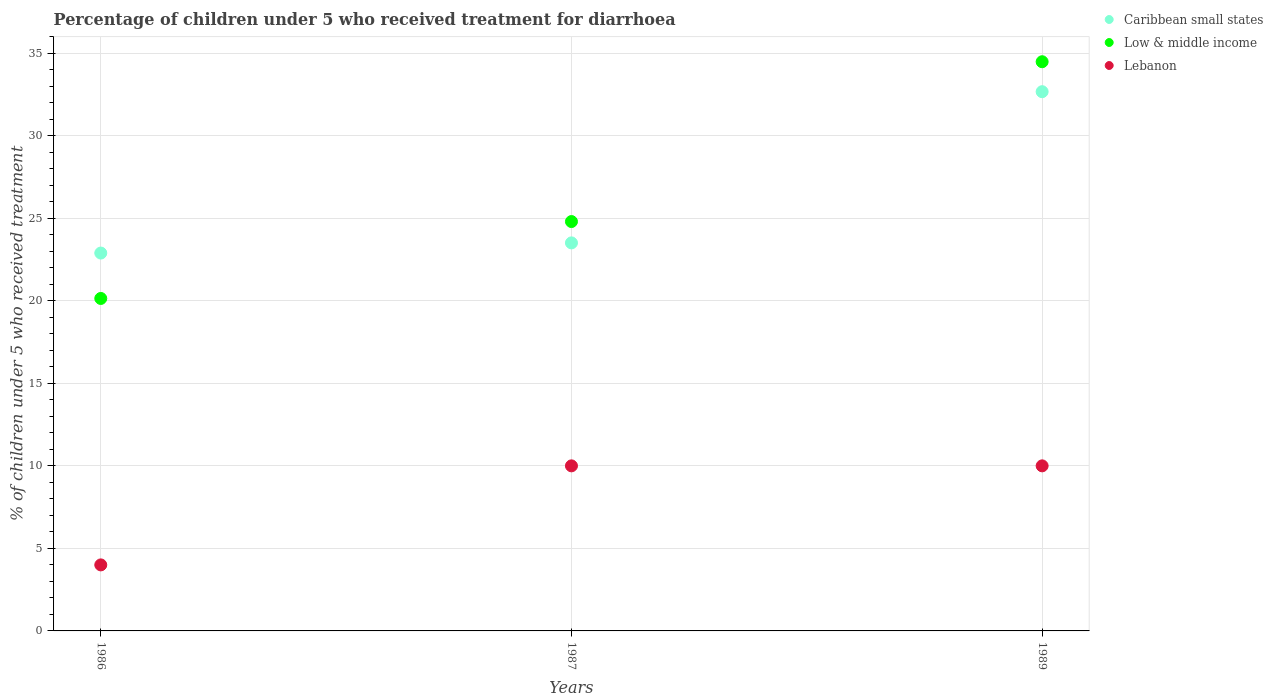What is the percentage of children who received treatment for diarrhoea  in Low & middle income in 1987?
Provide a short and direct response. 24.8. Across all years, what is the maximum percentage of children who received treatment for diarrhoea  in Caribbean small states?
Ensure brevity in your answer.  32.67. Across all years, what is the minimum percentage of children who received treatment for diarrhoea  in Caribbean small states?
Offer a terse response. 22.89. In which year was the percentage of children who received treatment for diarrhoea  in Low & middle income maximum?
Make the answer very short. 1989. What is the total percentage of children who received treatment for diarrhoea  in Low & middle income in the graph?
Give a very brief answer. 79.42. What is the difference between the percentage of children who received treatment for diarrhoea  in Caribbean small states in 1986 and that in 1989?
Give a very brief answer. -9.78. What is the difference between the percentage of children who received treatment for diarrhoea  in Caribbean small states in 1989 and the percentage of children who received treatment for diarrhoea  in Lebanon in 1987?
Provide a succinct answer. 22.67. What is the average percentage of children who received treatment for diarrhoea  in Low & middle income per year?
Ensure brevity in your answer.  26.47. In the year 1986, what is the difference between the percentage of children who received treatment for diarrhoea  in Lebanon and percentage of children who received treatment for diarrhoea  in Caribbean small states?
Your response must be concise. -18.89. In how many years, is the percentage of children who received treatment for diarrhoea  in Lebanon greater than 27 %?
Give a very brief answer. 0. What is the ratio of the percentage of children who received treatment for diarrhoea  in Caribbean small states in 1986 to that in 1989?
Keep it short and to the point. 0.7. Is the percentage of children who received treatment for diarrhoea  in Lebanon in 1986 less than that in 1989?
Provide a succinct answer. Yes. What is the difference between the highest and the second highest percentage of children who received treatment for diarrhoea  in Low & middle income?
Ensure brevity in your answer.  9.68. What is the difference between the highest and the lowest percentage of children who received treatment for diarrhoea  in Low & middle income?
Your response must be concise. 14.34. In how many years, is the percentage of children who received treatment for diarrhoea  in Low & middle income greater than the average percentage of children who received treatment for diarrhoea  in Low & middle income taken over all years?
Give a very brief answer. 1. Is the percentage of children who received treatment for diarrhoea  in Caribbean small states strictly greater than the percentage of children who received treatment for diarrhoea  in Lebanon over the years?
Offer a very short reply. Yes. How many dotlines are there?
Your response must be concise. 3. Does the graph contain any zero values?
Provide a short and direct response. No. Where does the legend appear in the graph?
Your answer should be compact. Top right. How many legend labels are there?
Give a very brief answer. 3. How are the legend labels stacked?
Your response must be concise. Vertical. What is the title of the graph?
Offer a terse response. Percentage of children under 5 who received treatment for diarrhoea. Does "Ecuador" appear as one of the legend labels in the graph?
Ensure brevity in your answer.  No. What is the label or title of the X-axis?
Your answer should be very brief. Years. What is the label or title of the Y-axis?
Provide a succinct answer. % of children under 5 who received treatment. What is the % of children under 5 who received treatment of Caribbean small states in 1986?
Provide a short and direct response. 22.89. What is the % of children under 5 who received treatment in Low & middle income in 1986?
Provide a succinct answer. 20.14. What is the % of children under 5 who received treatment in Caribbean small states in 1987?
Offer a very short reply. 23.51. What is the % of children under 5 who received treatment of Low & middle income in 1987?
Make the answer very short. 24.8. What is the % of children under 5 who received treatment of Caribbean small states in 1989?
Offer a very short reply. 32.67. What is the % of children under 5 who received treatment of Low & middle income in 1989?
Make the answer very short. 34.48. Across all years, what is the maximum % of children under 5 who received treatment in Caribbean small states?
Your answer should be very brief. 32.67. Across all years, what is the maximum % of children under 5 who received treatment in Low & middle income?
Make the answer very short. 34.48. Across all years, what is the minimum % of children under 5 who received treatment of Caribbean small states?
Your answer should be compact. 22.89. Across all years, what is the minimum % of children under 5 who received treatment of Low & middle income?
Make the answer very short. 20.14. What is the total % of children under 5 who received treatment of Caribbean small states in the graph?
Offer a very short reply. 79.07. What is the total % of children under 5 who received treatment in Low & middle income in the graph?
Offer a very short reply. 79.42. What is the difference between the % of children under 5 who received treatment in Caribbean small states in 1986 and that in 1987?
Provide a succinct answer. -0.62. What is the difference between the % of children under 5 who received treatment in Low & middle income in 1986 and that in 1987?
Give a very brief answer. -4.66. What is the difference between the % of children under 5 who received treatment in Caribbean small states in 1986 and that in 1989?
Give a very brief answer. -9.78. What is the difference between the % of children under 5 who received treatment in Low & middle income in 1986 and that in 1989?
Make the answer very short. -14.34. What is the difference between the % of children under 5 who received treatment of Caribbean small states in 1987 and that in 1989?
Keep it short and to the point. -9.16. What is the difference between the % of children under 5 who received treatment in Low & middle income in 1987 and that in 1989?
Provide a short and direct response. -9.68. What is the difference between the % of children under 5 who received treatment in Lebanon in 1987 and that in 1989?
Provide a short and direct response. 0. What is the difference between the % of children under 5 who received treatment of Caribbean small states in 1986 and the % of children under 5 who received treatment of Low & middle income in 1987?
Ensure brevity in your answer.  -1.91. What is the difference between the % of children under 5 who received treatment in Caribbean small states in 1986 and the % of children under 5 who received treatment in Lebanon in 1987?
Your answer should be compact. 12.89. What is the difference between the % of children under 5 who received treatment of Low & middle income in 1986 and the % of children under 5 who received treatment of Lebanon in 1987?
Offer a terse response. 10.14. What is the difference between the % of children under 5 who received treatment in Caribbean small states in 1986 and the % of children under 5 who received treatment in Low & middle income in 1989?
Provide a short and direct response. -11.59. What is the difference between the % of children under 5 who received treatment of Caribbean small states in 1986 and the % of children under 5 who received treatment of Lebanon in 1989?
Provide a succinct answer. 12.89. What is the difference between the % of children under 5 who received treatment in Low & middle income in 1986 and the % of children under 5 who received treatment in Lebanon in 1989?
Provide a short and direct response. 10.14. What is the difference between the % of children under 5 who received treatment of Caribbean small states in 1987 and the % of children under 5 who received treatment of Low & middle income in 1989?
Offer a very short reply. -10.97. What is the difference between the % of children under 5 who received treatment in Caribbean small states in 1987 and the % of children under 5 who received treatment in Lebanon in 1989?
Offer a very short reply. 13.51. What is the difference between the % of children under 5 who received treatment of Low & middle income in 1987 and the % of children under 5 who received treatment of Lebanon in 1989?
Keep it short and to the point. 14.8. What is the average % of children under 5 who received treatment of Caribbean small states per year?
Ensure brevity in your answer.  26.36. What is the average % of children under 5 who received treatment of Low & middle income per year?
Keep it short and to the point. 26.47. What is the average % of children under 5 who received treatment in Lebanon per year?
Keep it short and to the point. 8. In the year 1986, what is the difference between the % of children under 5 who received treatment of Caribbean small states and % of children under 5 who received treatment of Low & middle income?
Make the answer very short. 2.75. In the year 1986, what is the difference between the % of children under 5 who received treatment in Caribbean small states and % of children under 5 who received treatment in Lebanon?
Keep it short and to the point. 18.89. In the year 1986, what is the difference between the % of children under 5 who received treatment of Low & middle income and % of children under 5 who received treatment of Lebanon?
Ensure brevity in your answer.  16.14. In the year 1987, what is the difference between the % of children under 5 who received treatment in Caribbean small states and % of children under 5 who received treatment in Low & middle income?
Ensure brevity in your answer.  -1.29. In the year 1987, what is the difference between the % of children under 5 who received treatment in Caribbean small states and % of children under 5 who received treatment in Lebanon?
Give a very brief answer. 13.51. In the year 1987, what is the difference between the % of children under 5 who received treatment in Low & middle income and % of children under 5 who received treatment in Lebanon?
Provide a short and direct response. 14.8. In the year 1989, what is the difference between the % of children under 5 who received treatment in Caribbean small states and % of children under 5 who received treatment in Low & middle income?
Your response must be concise. -1.81. In the year 1989, what is the difference between the % of children under 5 who received treatment of Caribbean small states and % of children under 5 who received treatment of Lebanon?
Keep it short and to the point. 22.67. In the year 1989, what is the difference between the % of children under 5 who received treatment of Low & middle income and % of children under 5 who received treatment of Lebanon?
Ensure brevity in your answer.  24.48. What is the ratio of the % of children under 5 who received treatment of Caribbean small states in 1986 to that in 1987?
Provide a short and direct response. 0.97. What is the ratio of the % of children under 5 who received treatment of Low & middle income in 1986 to that in 1987?
Provide a succinct answer. 0.81. What is the ratio of the % of children under 5 who received treatment in Caribbean small states in 1986 to that in 1989?
Make the answer very short. 0.7. What is the ratio of the % of children under 5 who received treatment of Low & middle income in 1986 to that in 1989?
Keep it short and to the point. 0.58. What is the ratio of the % of children under 5 who received treatment in Caribbean small states in 1987 to that in 1989?
Provide a short and direct response. 0.72. What is the ratio of the % of children under 5 who received treatment in Low & middle income in 1987 to that in 1989?
Offer a terse response. 0.72. What is the difference between the highest and the second highest % of children under 5 who received treatment in Caribbean small states?
Provide a short and direct response. 9.16. What is the difference between the highest and the second highest % of children under 5 who received treatment in Low & middle income?
Provide a succinct answer. 9.68. What is the difference between the highest and the second highest % of children under 5 who received treatment in Lebanon?
Offer a terse response. 0. What is the difference between the highest and the lowest % of children under 5 who received treatment of Caribbean small states?
Your answer should be compact. 9.78. What is the difference between the highest and the lowest % of children under 5 who received treatment of Low & middle income?
Your answer should be very brief. 14.34. What is the difference between the highest and the lowest % of children under 5 who received treatment in Lebanon?
Give a very brief answer. 6. 